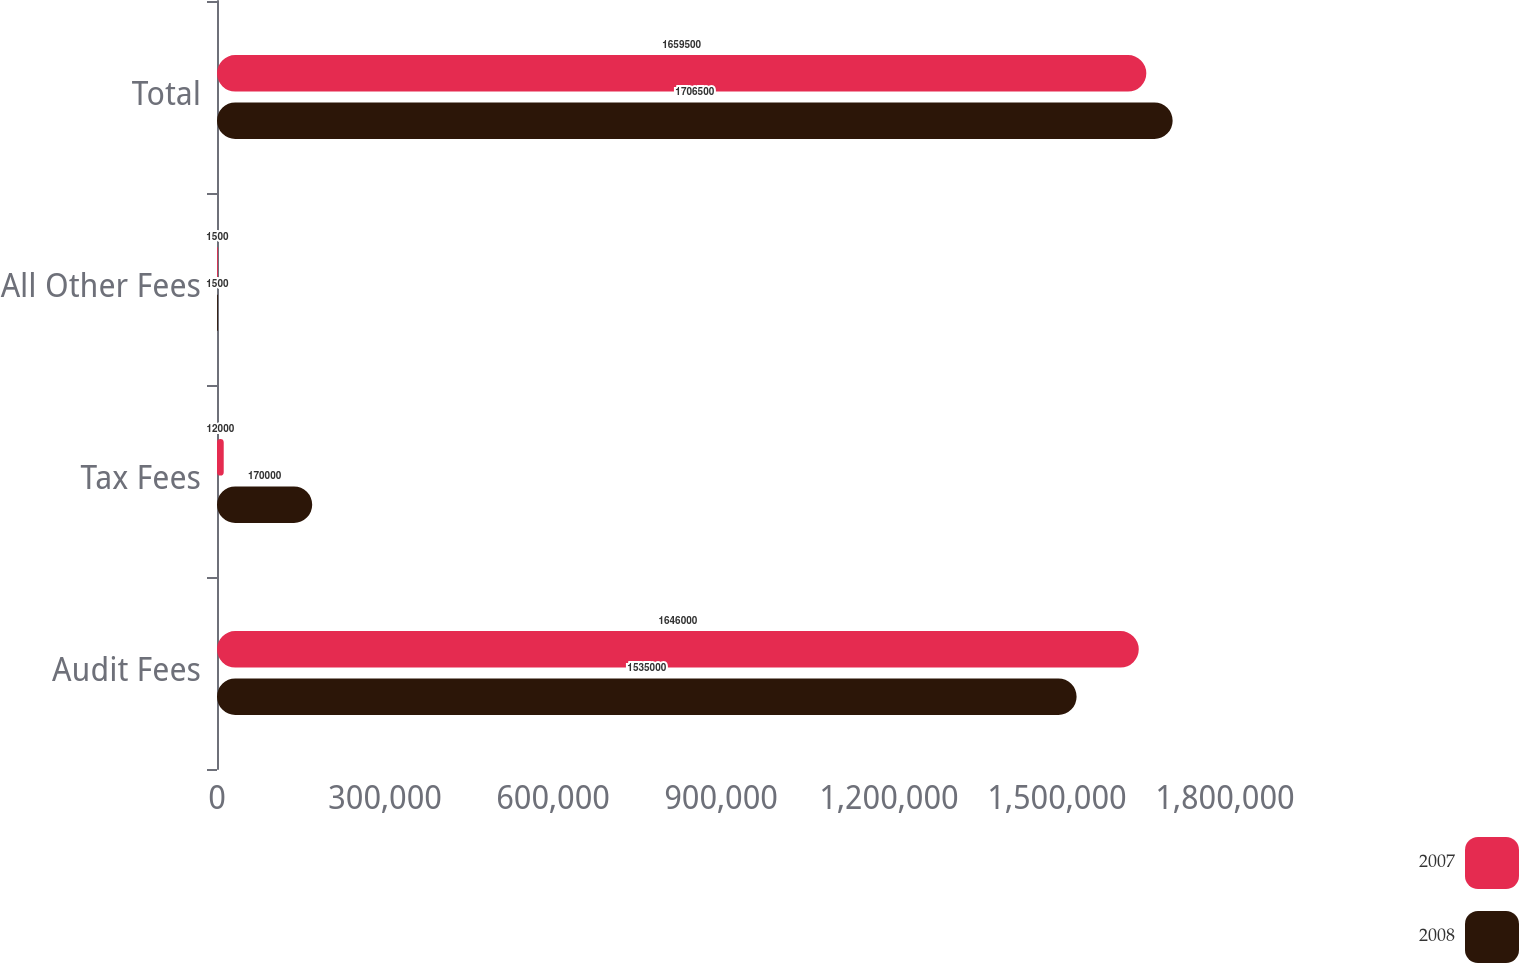<chart> <loc_0><loc_0><loc_500><loc_500><stacked_bar_chart><ecel><fcel>Audit Fees<fcel>Tax Fees<fcel>All Other Fees<fcel>Total<nl><fcel>2007<fcel>1.646e+06<fcel>12000<fcel>1500<fcel>1.6595e+06<nl><fcel>2008<fcel>1.535e+06<fcel>170000<fcel>1500<fcel>1.7065e+06<nl></chart> 